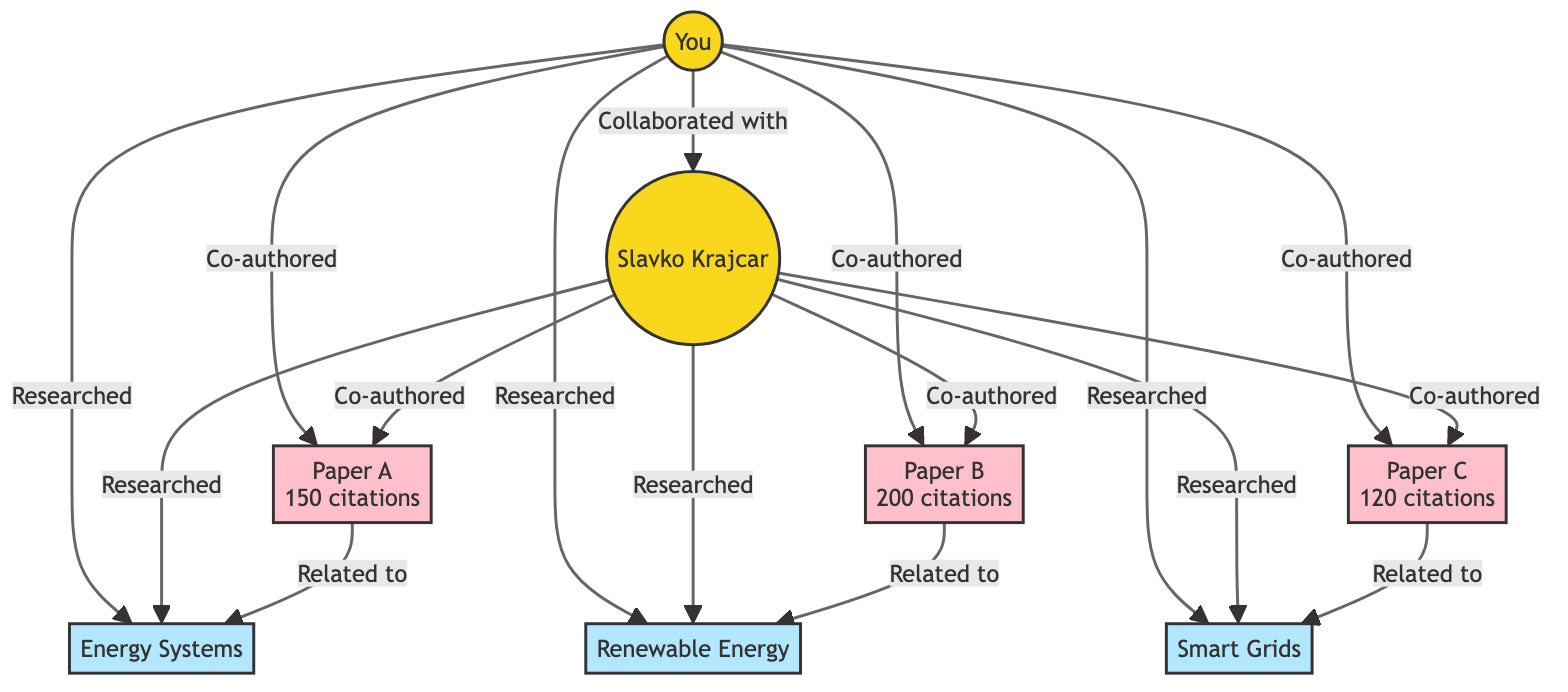What are the key research areas represented in the diagram? The diagram depicts three key research areas: Energy Systems, Renewable Energy, and Smart Grids. These areas are clearly labeled and connected to the professors in the diagram.
Answer: Energy Systems, Renewable Energy, Smart Grids How many papers were co-authored by you and Slavko Krajcar? The diagram illustrates that three papers (Paper A, Paper B, and Paper C) were co-authored by you and Slavko Krajcar. Each publication is specifically connected to both professors, indicating their joint authorship.
Answer: 3 What is the citation count for Paper B? Paper B is associated with the citation count of 200, as indicated in the diagram where the paper is labeled with its citation information.
Answer: 200 Which research area is related to Paper A? Paper A is linked to the research area Energy Systems, as shown by the connection between the paper and the research area in the diagram.
Answer: Energy Systems Who has collaborated with Slavko Krajcar according to the diagram? The diagram explicitly indicates that you have collaborated with Slavko Krajcar, as shown by the direct collaboration arrow between the two professors.
Answer: You How many total citations are received by all papers co-authored? To find the total citations, we sum the citations of all papers: 150 (Paper A) + 200 (Paper B) + 120 (Paper C) = 470 total citations across the three papers as represented in the diagram.
Answer: 470 Which research areas did both you and Slavko Krajcar research? The diagram shows that both you and Slavko Krajcar have researched Energy Systems, Renewable Energy, and Smart Grids, with each area connected to both professors.
Answer: Energy Systems, Renewable Energy, Smart Grids What is the relationship between Paper C and Smart Grids? Paper C is directly related to Smart Grids, as indicated by the link drawn between the publication and the research area in the diagram.
Answer: Related to Smart Grids Which professor authored Paper A? Both you and Slavko Krajcar co-authored Paper A, as indicated by the collaboration links connecting the paper to each professor in the diagram.
Answer: You, Slavko Krajcar 